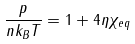Convert formula to latex. <formula><loc_0><loc_0><loc_500><loc_500>\frac { p } { n k _ { B } T } = 1 + 4 \eta \chi _ { e q }</formula> 